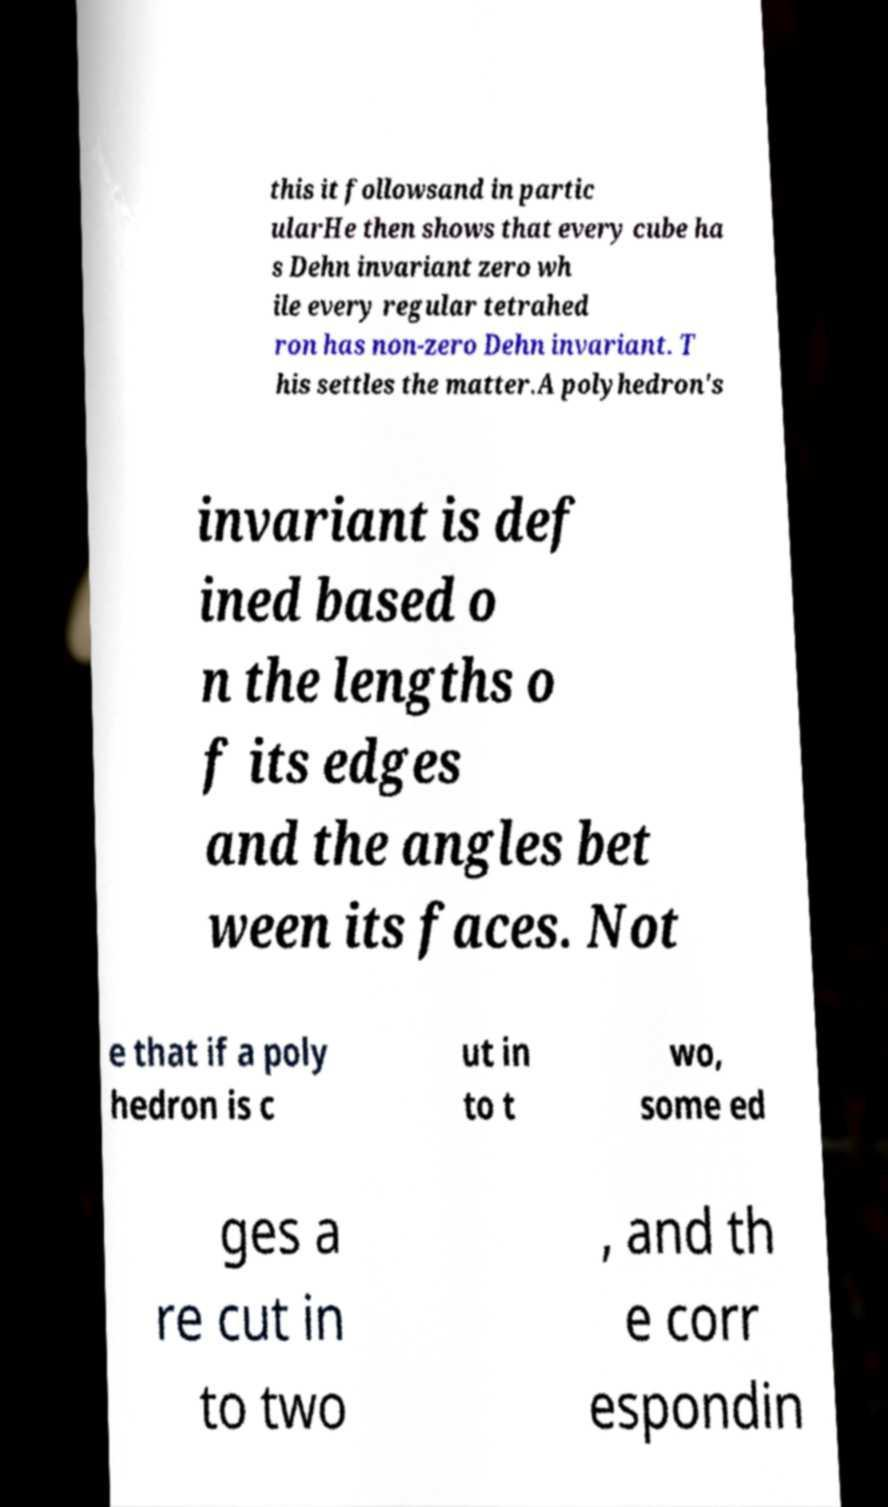Can you read and provide the text displayed in the image?This photo seems to have some interesting text. Can you extract and type it out for me? this it followsand in partic ularHe then shows that every cube ha s Dehn invariant zero wh ile every regular tetrahed ron has non-zero Dehn invariant. T his settles the matter.A polyhedron's invariant is def ined based o n the lengths o f its edges and the angles bet ween its faces. Not e that if a poly hedron is c ut in to t wo, some ed ges a re cut in to two , and th e corr espondin 